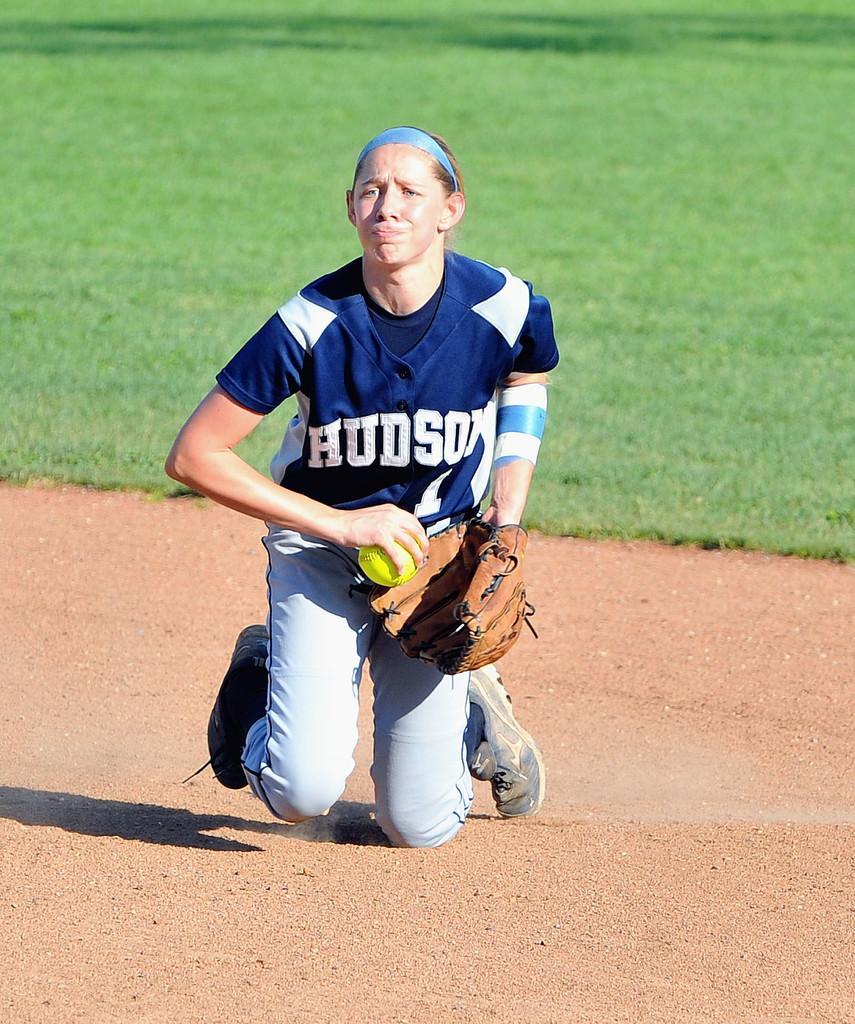How would you summarize this image in a sentence or two? In this image in the center there is one woman who is holding a ball and wearing a gloves and she is sitting on her knees. At the bottom there is sand, and in the background there is grass. 